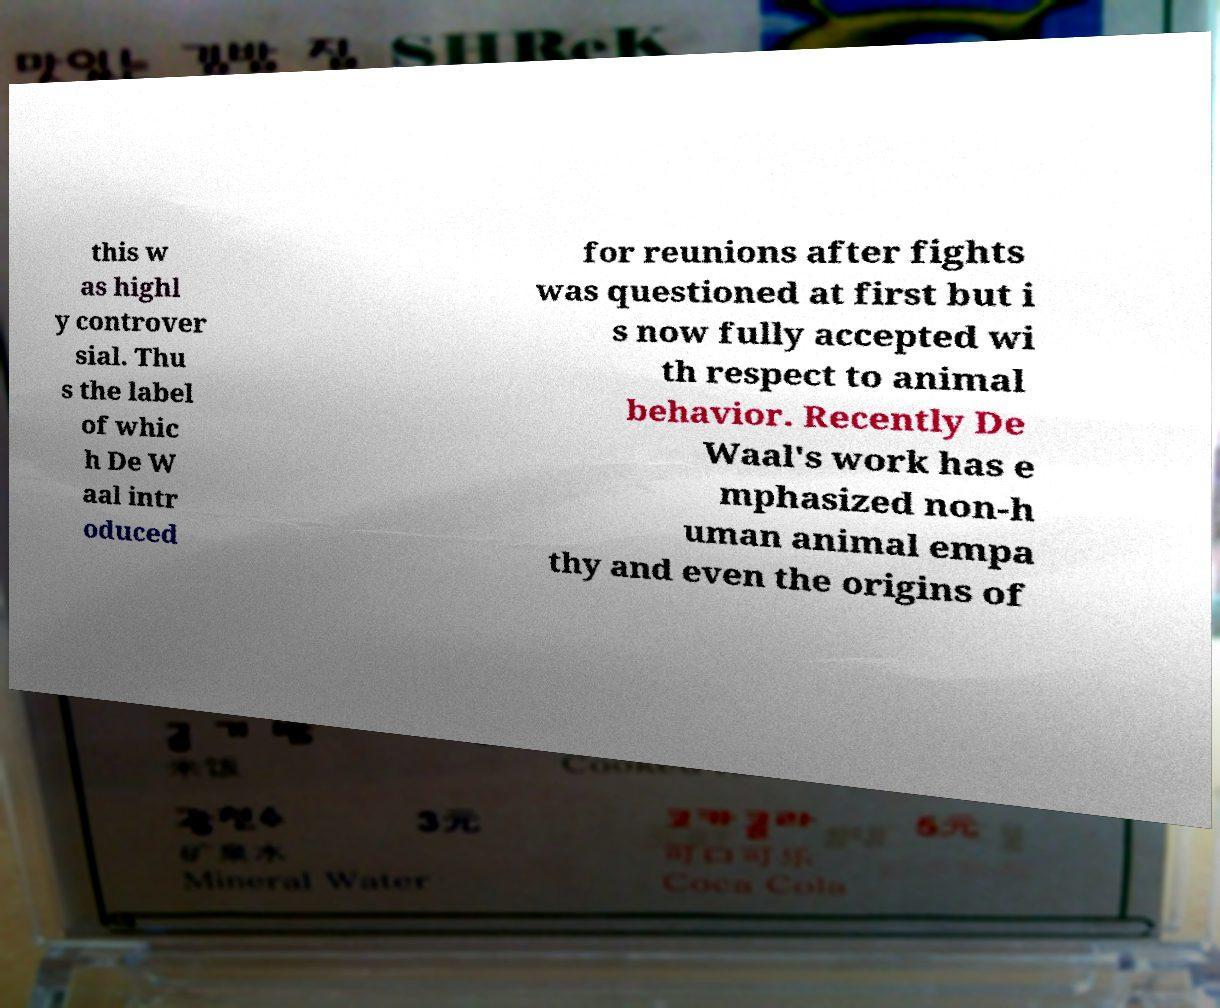There's text embedded in this image that I need extracted. Can you transcribe it verbatim? this w as highl y controver sial. Thu s the label of whic h De W aal intr oduced for reunions after fights was questioned at first but i s now fully accepted wi th respect to animal behavior. Recently De Waal's work has e mphasized non-h uman animal empa thy and even the origins of 